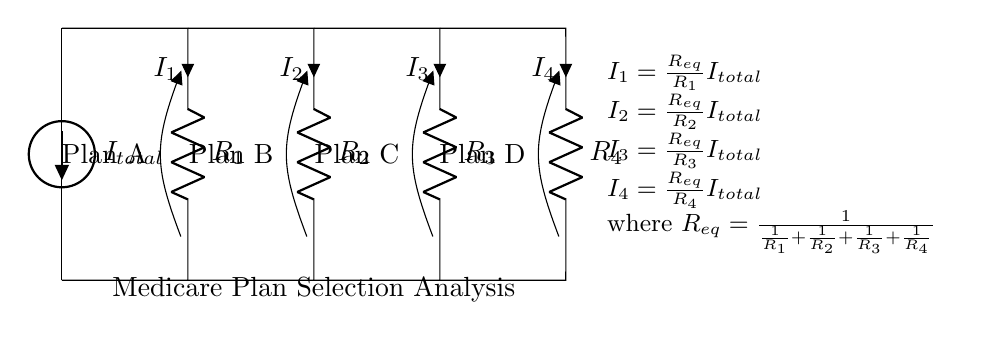What does the current source in this circuit represent? The current source represents the total current flowing into the circuit, denoted as I total. It provides the initial condition for the current division among the resistors.
Answer: I total What is the value of R1 in the circuit? R1 is the resistor associated with Plan A's current, but its specific value is not provided on the diagram, only its label is present. It is marked as R1.
Answer: R1 How do you calculate I2? I2 is calculated using the formula I2 = (R_eq/R2) * I_total, where R_eq is the equivalent resistance of the parallel resistors. This involves first determining R_eq and then applying the formula.
Answer: R_eq/R2 * I_total Which Medicare plan has the highest current? To determine which plan has the highest current, we compare I1, I2, I3, and I4, which depend on the respective resistances R1, R2, R3, and R4. The plan with the lowest resistance will have the highest current due to the current divider principle.
Answer: Depends on R1, R2, R3, and R4 What is the equivalent resistance of the circuit? The equivalent resistance R_eq is calculated using the formula R_eq = 1/(1/R1 + 1/R2 + 1/R3 + 1/R4). This involves calculating the reciprocal of the sum of the reciprocals of the individual resistances.
Answer: 1/(1/R1 + 1/R2 + 1/R3 + 1/R4) What relationship does current have with resistance in this circuit? The current through each branch is inversely proportional to the resistance of that branch, which means lower resistance results in higher current, consistent with the behavior of a current divider.
Answer: Inversely proportional How is the total current divided among the plans? The total current I_total is divided among the four branches such that I1, I2, I3, and I4 each represent a fraction of I_total based on the respective resistances, following the current divider rule.
Answer: Based on resistance values 